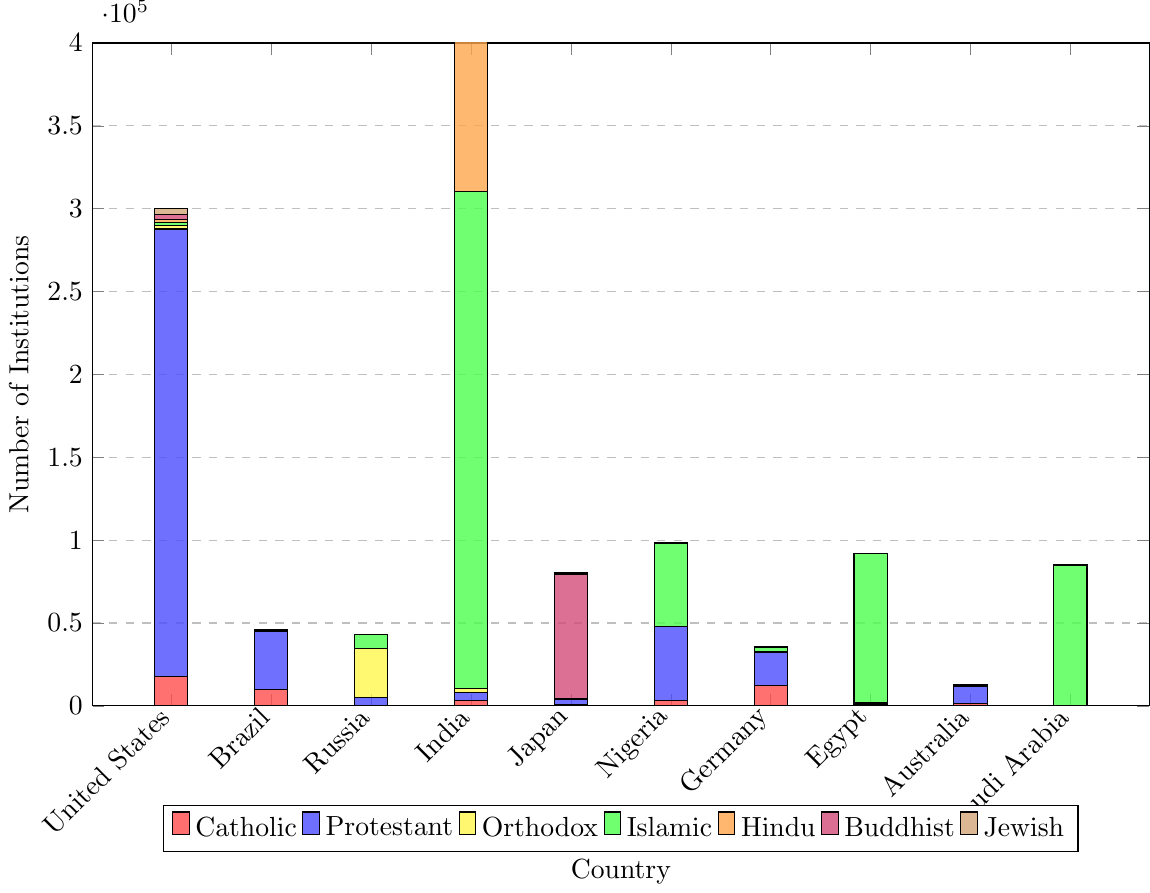Which country has the highest number of Protestant institutions? Observe the figure and identify the tallest blue bar representing Protestant institutions. This bar corresponds to the United States.
Answer: United States Which two denominations have the highest number of institutions in India? Identify the highest bars for India. The green bar (Islamic) and the orange bar (Hindu) are the highest.
Answer: Islamic and Hindu How many more Catholic institutions are there in Germany compared to Russia? The height of the red bars corresponding to Catholic institutions in Germany and Russia are 12000 and 300, respectively. Subtract the smaller value from the larger one: 12000 - 300.
Answer: 11700 Which countries have no Hindu institutions? Notice the absence of the orange bar in the plots for specific countries. The countries without orange bars are Saudi Arabia and Egypt.
Answer: Saudi Arabia and Egypt What is the total number of religious institutions in Japan? Sum up the heights of all the bars for Japan: 1000 (Catholic) + 3000 (Protestant) + 50 (Orthodox) + 100 (Islamic) + 30 (Hindu) + 75000 (Buddhist) + 1000 (Jewish).
Answer: 80180 Which country has the fewest Islamic institutions? Look for the shortest green bar in the figure. Brazil has the shortest green bar with 100 institutions.
Answer: Brazil Compare the number of Buddhist institutions between Japan and Australia. Which country has more, and by how much? Identify the height of the purple bars representing Buddhist institutions in Japan and Australia: 75000 for Japan and 400 for Australia. Subtract the smaller value from the larger one: 75000 - 400.
Answer: Japan, 74600 How many Jewish institutions are there in Egypt? Locate the height of the brown bar for Egypt. The brown bar represents Jewish institutions, and its value is 12.
Answer: 12 What is the combined number of Protestant and Islamic institutions in Nigeria? Add the values of the blue and green bars for Nigeria: 45000 (Protestant) + 50000 (Islamic).
Answer: 95000 Which denomination has the least number of institutions in the United States? Compare the heights of all bars for the United States. The shortest bar is the orange one (Hindu) with 1600 institutions.
Answer: Hindu 